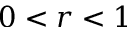Convert formula to latex. <formula><loc_0><loc_0><loc_500><loc_500>0 < r < 1</formula> 